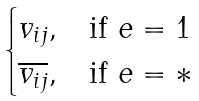<formula> <loc_0><loc_0><loc_500><loc_500>\begin{cases} v _ { i j } , & \text {if $e=1$} \\ \overline { v _ { i j } } , & \text {if $e=*$} \end{cases}</formula> 